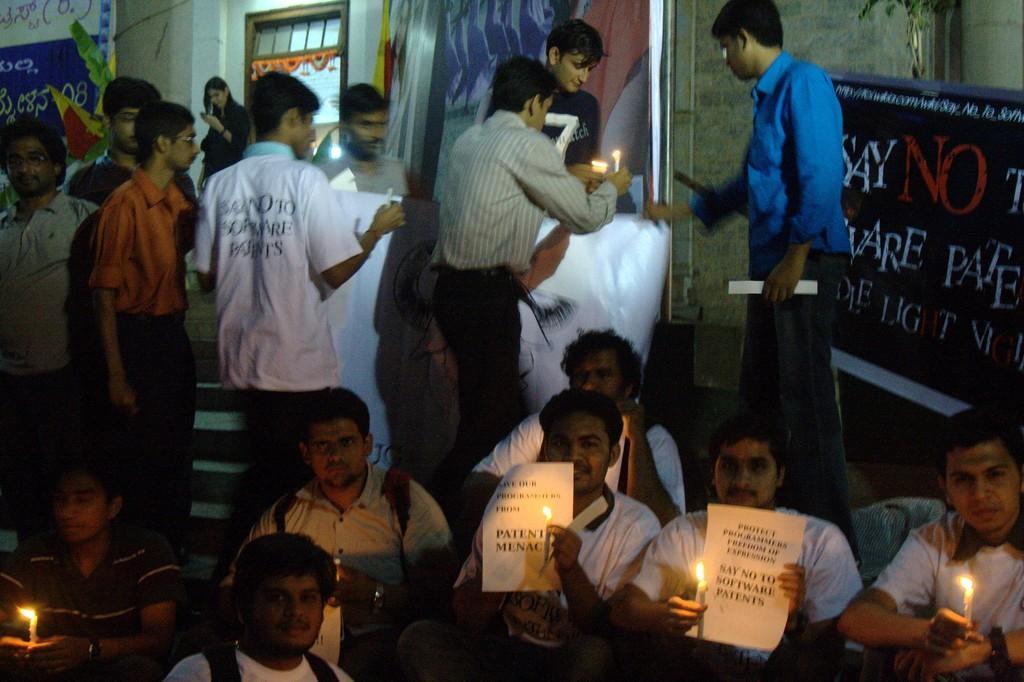Can you describe this image briefly? In this image there are few people sitting on floor and holding candles in their hand, in background few people standing and holding candles in there hand and there is a wall. 